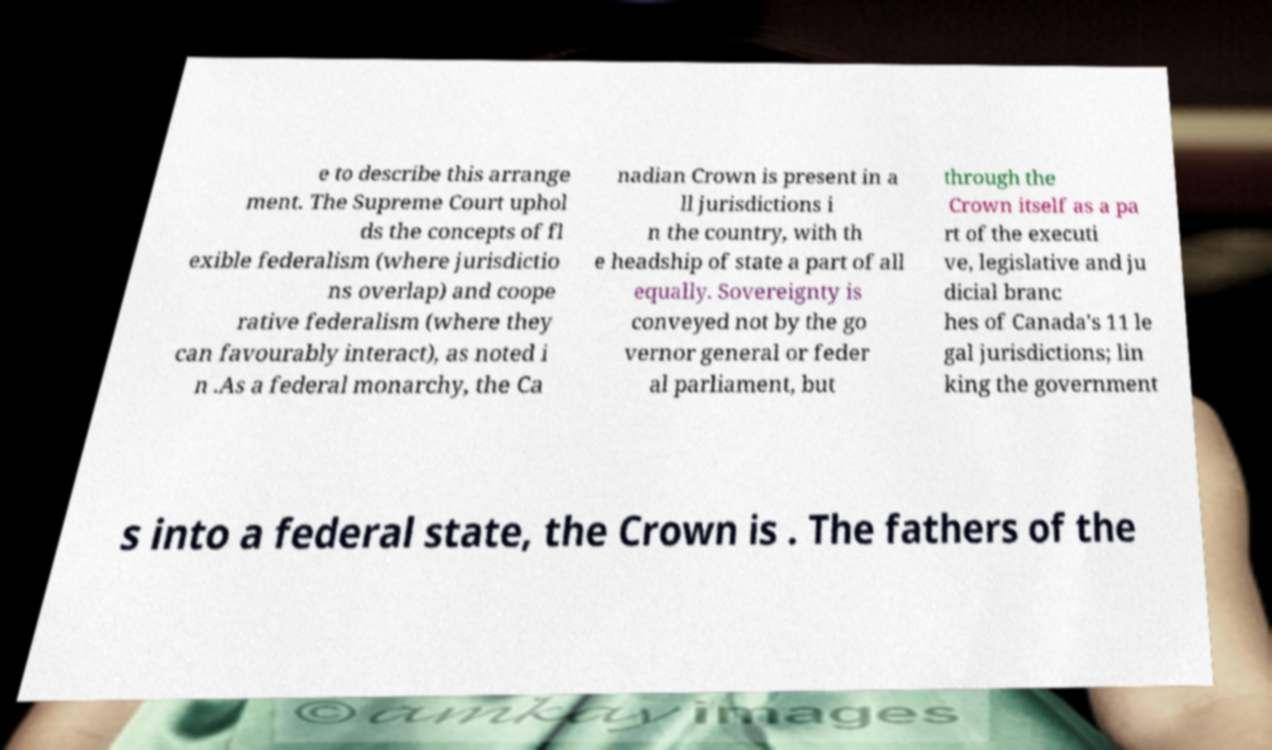What messages or text are displayed in this image? I need them in a readable, typed format. e to describe this arrange ment. The Supreme Court uphol ds the concepts of fl exible federalism (where jurisdictio ns overlap) and coope rative federalism (where they can favourably interact), as noted i n .As a federal monarchy, the Ca nadian Crown is present in a ll jurisdictions i n the country, with th e headship of state a part of all equally. Sovereignty is conveyed not by the go vernor general or feder al parliament, but through the Crown itself as a pa rt of the executi ve, legislative and ju dicial branc hes of Canada's 11 le gal jurisdictions; lin king the government s into a federal state, the Crown is . The fathers of the 